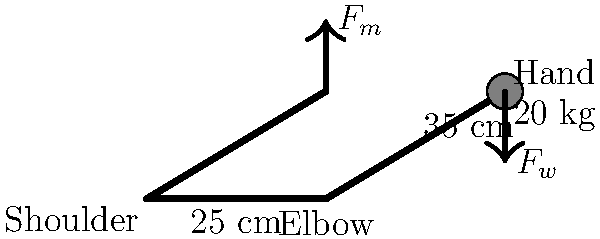As a day trader accustomed to analyzing market forces, consider this biomechanical scenario: A person is performing a bicep curl with a 20 kg weight. The distance from the elbow to the shoulder (bicep insertion) is 25 cm, and the distance from the elbow to the hand (where the weight is held) is 35 cm. Assuming the arm is held horizontally and the bicep force acts perpendicular to the upper arm, calculate the force exerted by the bicep muscle. How does this force calculation compare to analyzing leverage in financial markets? Let's approach this step-by-step, similar to how we might analyze a leveraged financial position:

1) First, identify the lever system:
   - The elbow joint acts as the fulcrum
   - The forearm is the lever
   - The weight provides the load force
   - The bicep muscle provides the effort force

2) Calculate the weight force ($F_w$):
   $F_w = 20 \text{ kg} \times 9.8 \text{ m/s}^2 = 196 \text{ N}$

3) Set up the moment equation. For equilibrium, the sum of moments about the elbow should be zero:
   $F_m \times 0.25 \text{ m} = F_w \times 0.35 \text{ m}$

4) Substitute the known values:
   $F_m \times 0.25 \text{ m} = 196 \text{ N} \times 0.35 \text{ m}$

5) Solve for $F_m$:
   $F_m = \frac{196 \text{ N} \times 0.35 \text{ m}}{0.25 \text{ m}} = 274.4 \text{ N}$

This calculation is analogous to analyzing leverage in financial markets. Just as a small movement in an underlying asset can result in a larger movement in a derivative's price due to leverage, here we see that the bicep must exert a force greater than the weight due to the mechanical disadvantage of the lever system.
Answer: 274.4 N 